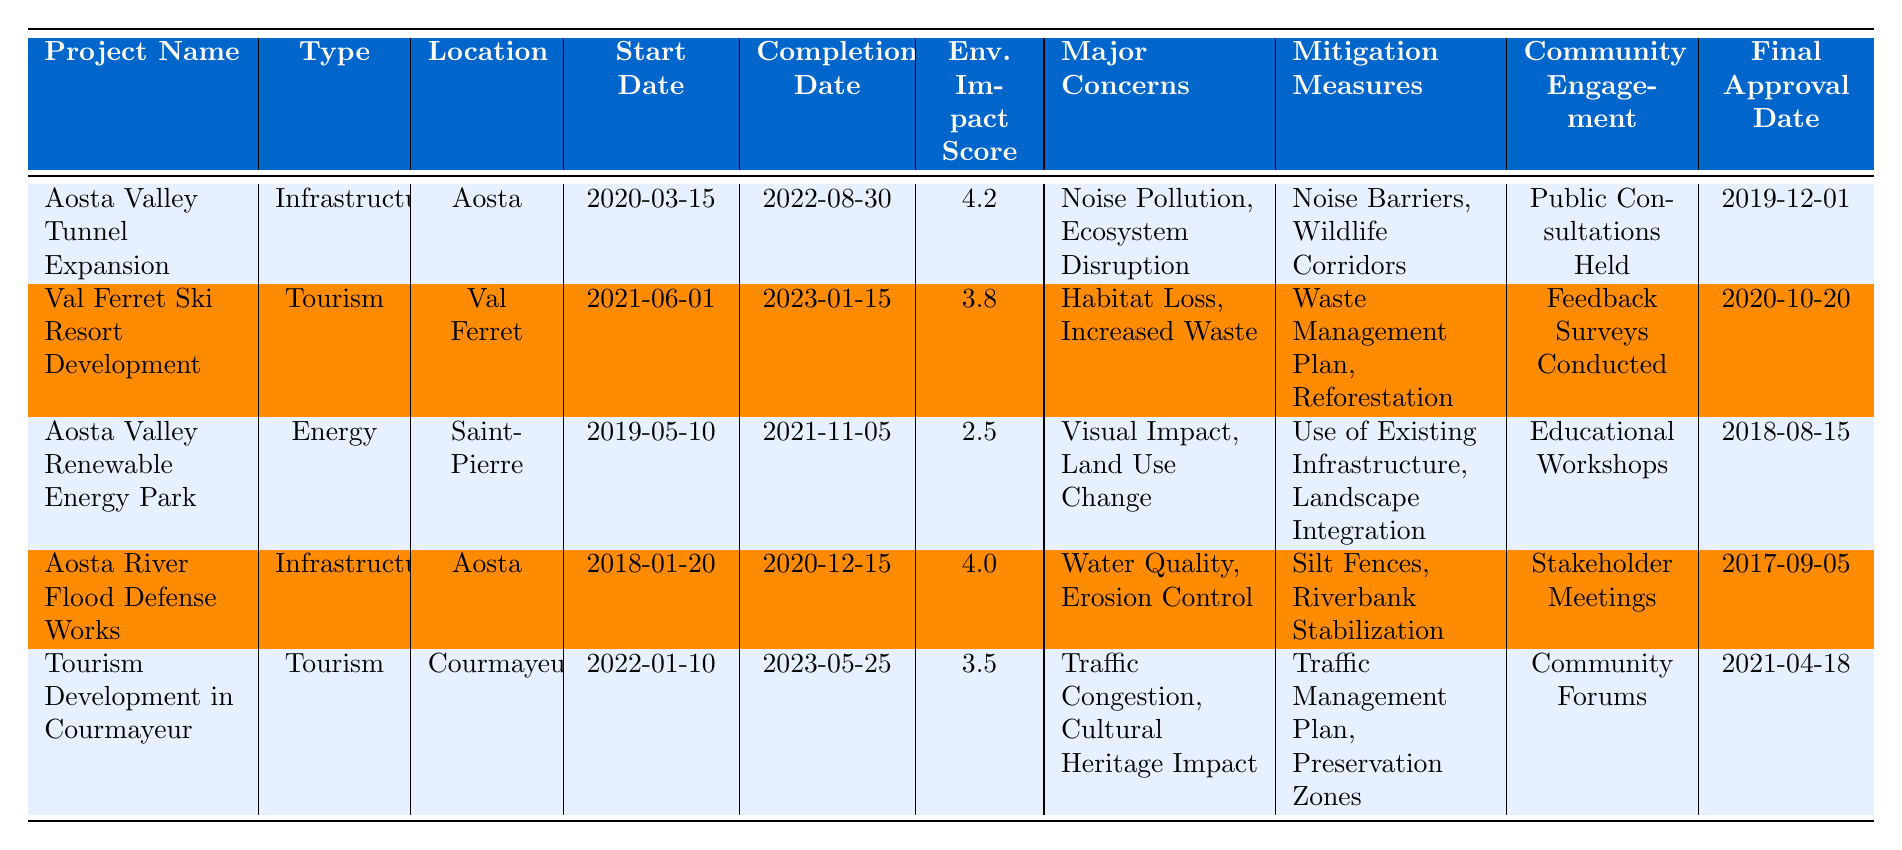What is the environmental impact score for the Aosta Valley Renewable Energy Park? The table shows the environmental impact score listed next to the project name "Aosta Valley Renewable Energy Park" as 2.5.
Answer: 2.5 Which project had the highest environmental impact score? Looking at the Environmental Impact Score column, the Aosta Valley Tunnel Expansion has the highest score of 4.2.
Answer: Aosta Valley Tunnel Expansion How many tourism projects are listed in the table? There are two projects categorized under tourism: "Val Ferret Ski Resort Development" and "Tourism Development in Courmayeur."
Answer: 2 What major concern is common between the Aosta Valley Tunnel Expansion and Aosta River Flood Defense Works? Both projects list "Ecosystem Disruption" for the Tunnel Expansion and "Erosion Control" for the Flood Defense, indicating common concerns about environmental impact, but there are no identical major concerns between the two.
Answer: No common major concerns What are the mitigation measures for the Val Ferret Ski Resort Development project? The table lists the mitigation measures for the Val Ferret Ski Resort Development as "Waste Management Plan" and "Reforestation."
Answer: Waste Management Plan, Reforestation Which project was approved last based on the final approval date? The final approval date for "Tourism Development in Courmayeur" is 2021-04-18, making it the last project approved among those listed.
Answer: Tourism Development in Courmayeur What is the difference in environmental impact scores between the highest and lowest scoring projects? The highest score is 4.2 (Aosta Valley Tunnel Expansion) and the lowest is 2.5 (Aosta Valley Renewable Energy Park); the difference is 4.2 - 2.5 = 1.7.
Answer: 1.7 How does the start date of the Aosta River Flood Defense Works compare to the completion date of the Aosta Valley Renewable Energy Park? The Aosta River Flood Defense Works started on 2018-01-20 and completed on 2020-12-15, while the Renewable Energy Park started on 2019-05-10 and completed on 2021-11-05, indicating that the Flood Defense project started earlier and finished before the Renewable Energy Park.
Answer: Flood Defense started earlier and finished first What type of community engagement method was used for the Aosta Valley Renewable Energy Park project? The table indicates that "Educational Workshops" were held as the community engagement method for this project.
Answer: Educational Workshops Did the Val Ferret Ski Resort Development project face any major concerns related to water? The major concerns for the Val Ferret Ski Resort Development were "Habitat Loss" and "Increased Waste," which do not include water-related concerns.
Answer: No Which project is categorized under the energy type and what was its environmental impact score? The "Aosta Valley Renewable Energy Park" is the only energy project, and its environmental impact score is 2.5.
Answer: Aosta Valley Renewable Energy Park, 2.5 